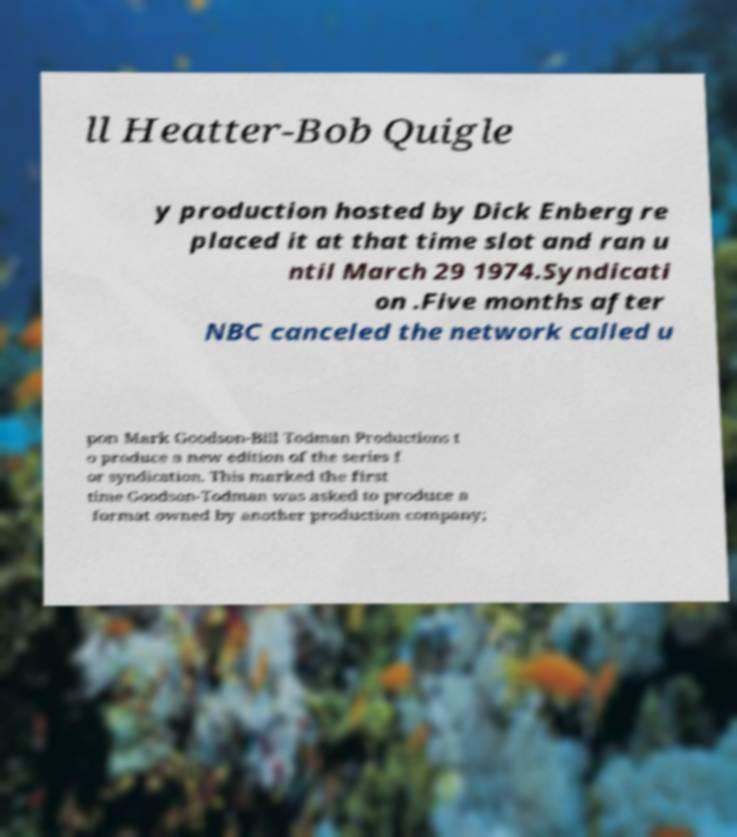There's text embedded in this image that I need extracted. Can you transcribe it verbatim? ll Heatter-Bob Quigle y production hosted by Dick Enberg re placed it at that time slot and ran u ntil March 29 1974.Syndicati on .Five months after NBC canceled the network called u pon Mark Goodson-Bill Todman Productions t o produce a new edition of the series f or syndication. This marked the first time Goodson-Todman was asked to produce a format owned by another production company; 